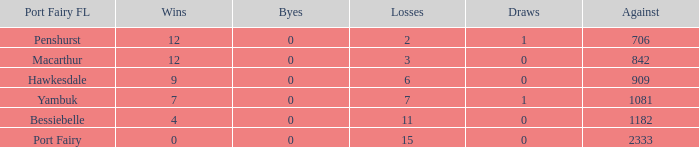How many wins for Port Fairy and against more than 2333? None. 